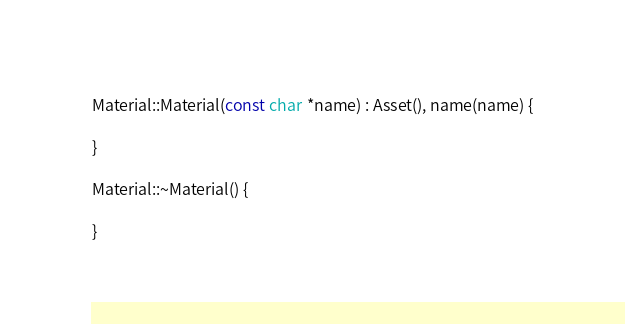Convert code to text. <code><loc_0><loc_0><loc_500><loc_500><_C++_>
Material::Material(const char *name) : Asset(), name(name) {

}

Material::~Material() {

}</code> 